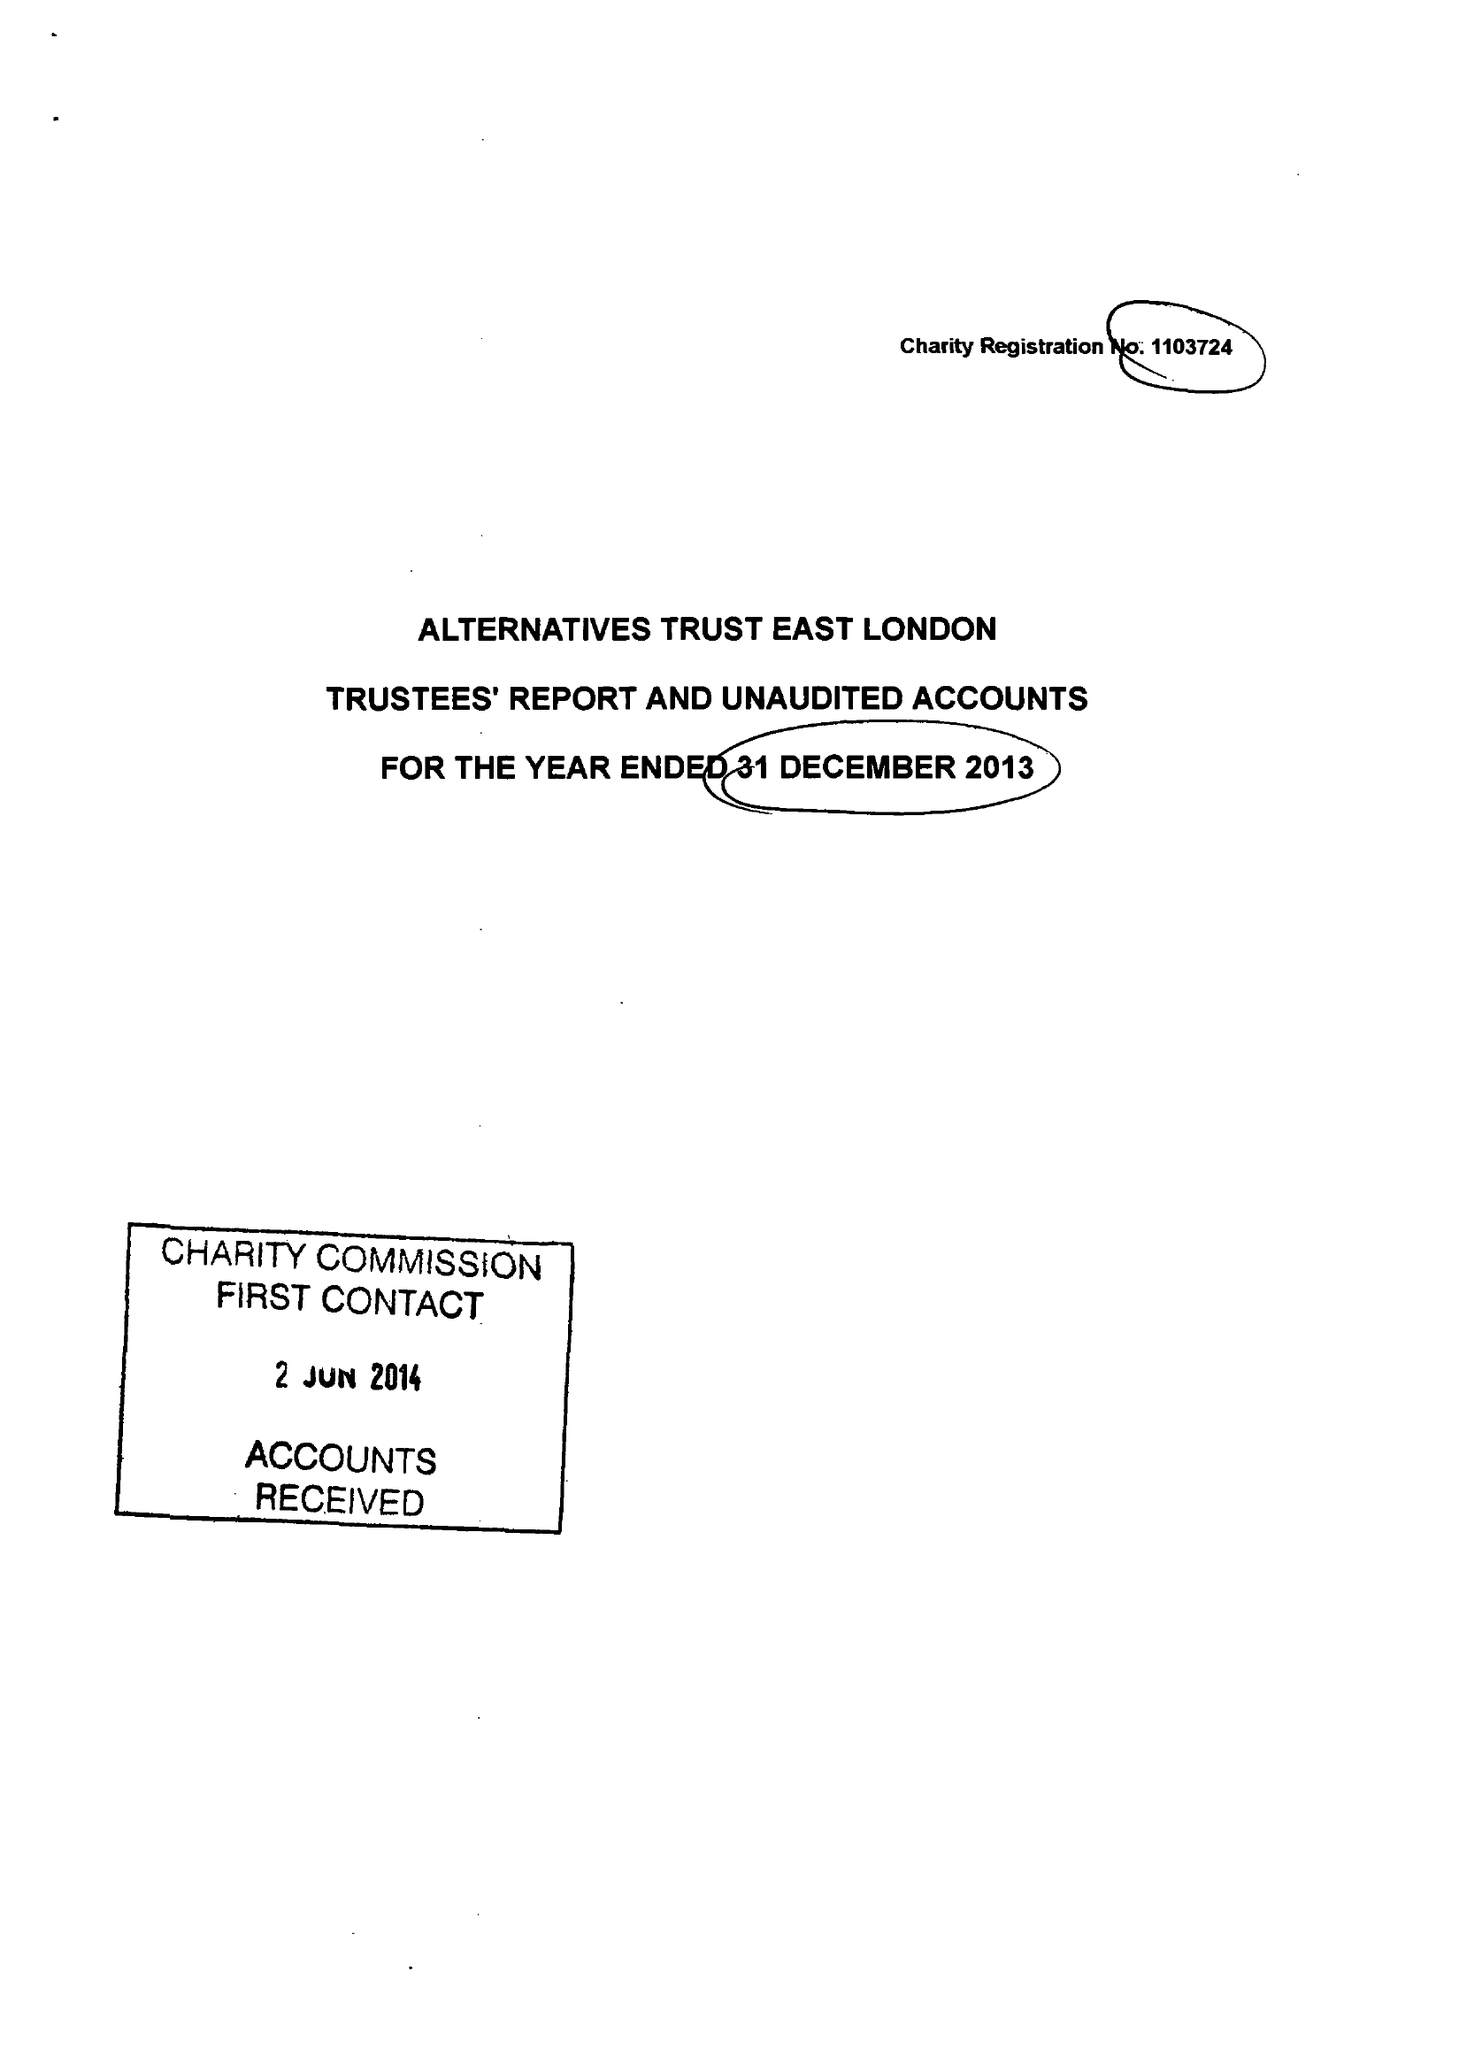What is the value for the income_annually_in_british_pounds?
Answer the question using a single word or phrase. 144159.00 